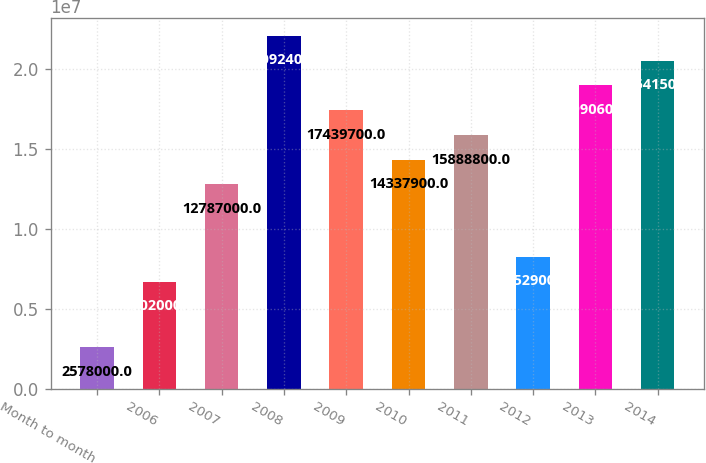<chart> <loc_0><loc_0><loc_500><loc_500><bar_chart><fcel>Month to month<fcel>2006<fcel>2007<fcel>2008<fcel>2009<fcel>2010<fcel>2011<fcel>2012<fcel>2013<fcel>2014<nl><fcel>2.578e+06<fcel>6.702e+06<fcel>1.2787e+07<fcel>2.20924e+07<fcel>1.74397e+07<fcel>1.43379e+07<fcel>1.58888e+07<fcel>8.2529e+06<fcel>1.89906e+07<fcel>2.05415e+07<nl></chart> 